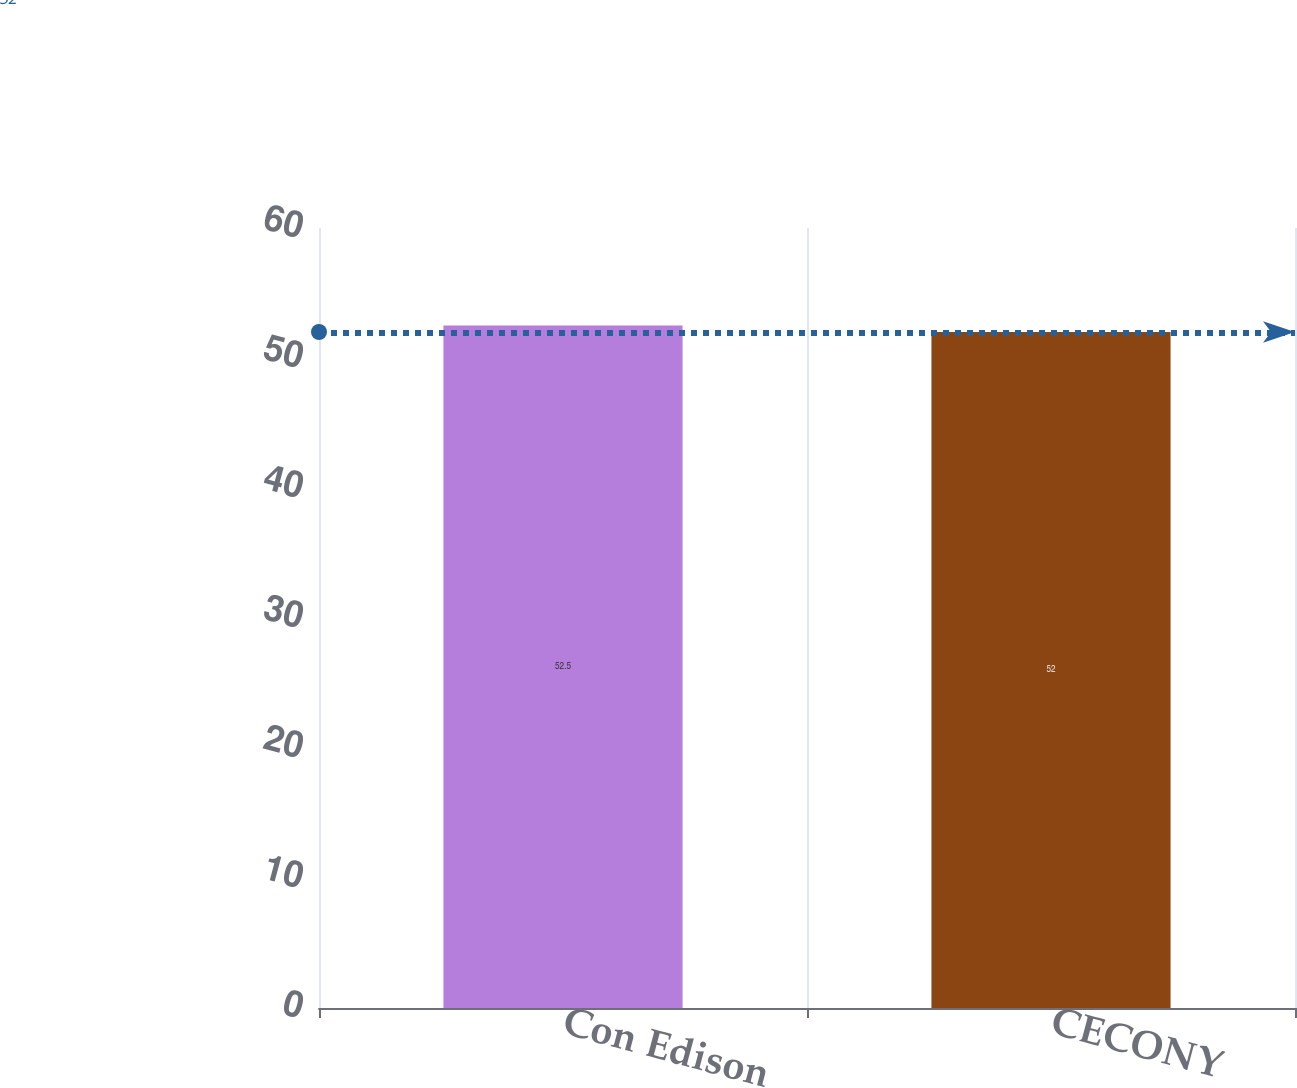Convert chart. <chart><loc_0><loc_0><loc_500><loc_500><bar_chart><fcel>Con Edison<fcel>CECONY<nl><fcel>52.5<fcel>52<nl></chart> 